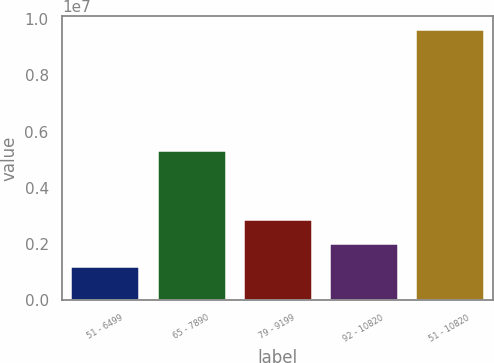<chart> <loc_0><loc_0><loc_500><loc_500><bar_chart><fcel>51 - 6499<fcel>65 - 7890<fcel>79 - 9199<fcel>92 - 10820<fcel>51 - 10820<nl><fcel>1.20558e+06<fcel>5.34185e+06<fcel>2.89243e+06<fcel>2.04901e+06<fcel>9.63985e+06<nl></chart> 